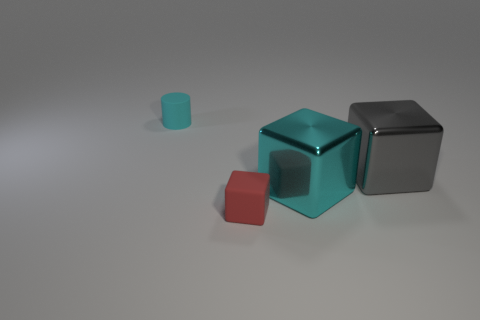How many other things are the same shape as the tiny cyan matte thing?
Offer a terse response. 0. How many objects are small things behind the large gray object or large blocks that are to the left of the large gray shiny cube?
Provide a short and direct response. 2. There is a thing that is to the left of the big cyan metal block and in front of the small cyan object; what size is it?
Keep it short and to the point. Small. There is a metal thing that is to the right of the big cyan metallic thing; is it the same shape as the tiny cyan rubber object?
Keep it short and to the point. No. What is the size of the matte object to the left of the small rubber object on the right side of the cylinder behind the large gray object?
Provide a succinct answer. Small. The cube that is the same color as the small matte cylinder is what size?
Your answer should be very brief. Large. What number of things are either small cyan cylinders or cyan things?
Your answer should be compact. 2. There is a object that is both in front of the gray metal block and behind the red rubber block; what shape is it?
Give a very brief answer. Cube. Is the shape of the gray metal thing the same as the thing left of the small red thing?
Offer a terse response. No. Are there any small cyan rubber objects on the right side of the gray metal cube?
Your answer should be very brief. No. 